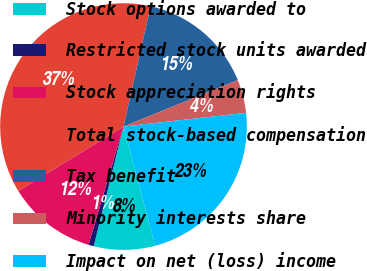<chart> <loc_0><loc_0><loc_500><loc_500><pie_chart><fcel>Stock options awarded to<fcel>Restricted stock units awarded<fcel>Stock appreciation rights<fcel>Total stock-based compensation<fcel>Tax benefit<fcel>Minority interests share<fcel>Impact on net (loss) income<nl><fcel>8.02%<fcel>0.7%<fcel>11.67%<fcel>37.27%<fcel>15.33%<fcel>4.36%<fcel>22.64%<nl></chart> 